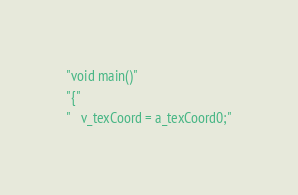Convert code to text. <code><loc_0><loc_0><loc_500><loc_500><_ObjectiveC_>"void main()"
"{"
"   v_texCoord = a_texCoord0;"</code> 